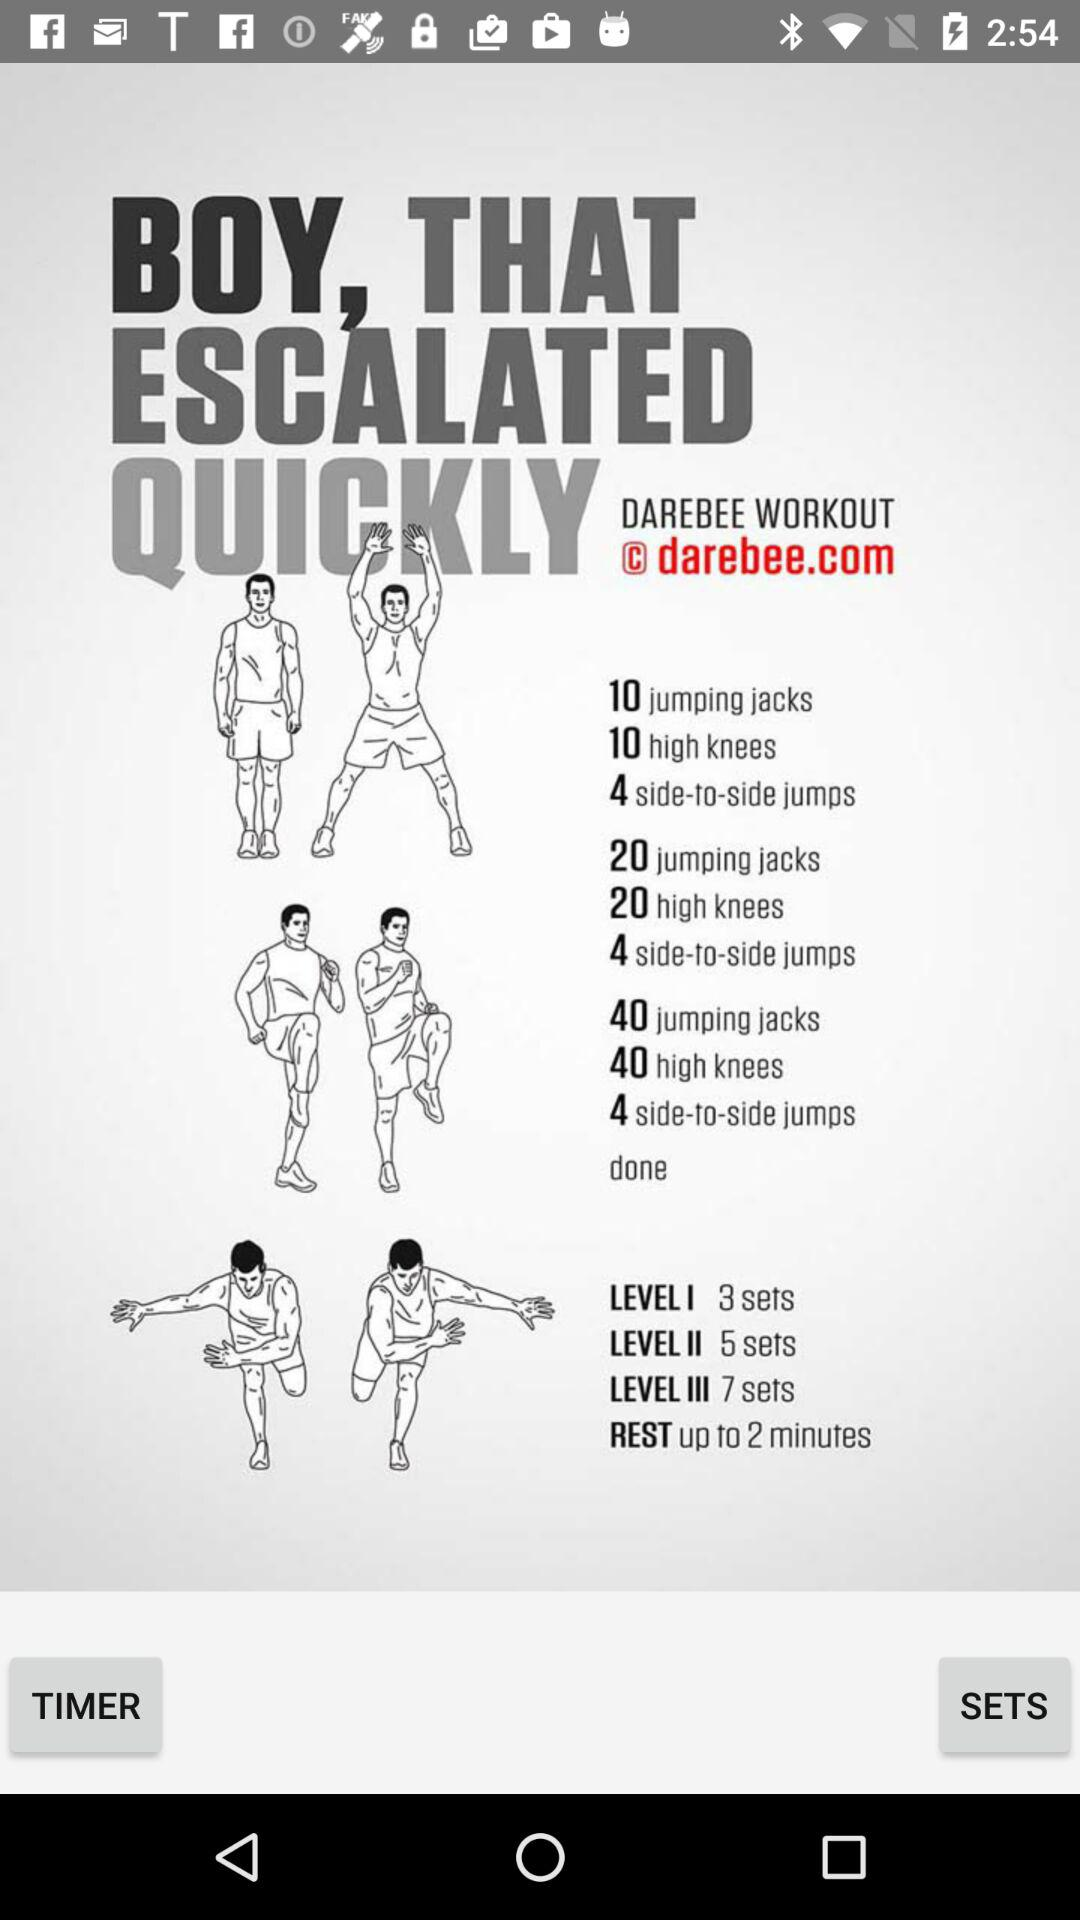How many sets are there for level III?
Answer the question using a single word or phrase. 7 